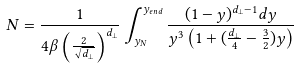<formula> <loc_0><loc_0><loc_500><loc_500>N = \frac { 1 } { 4 \beta \left ( \frac { 2 } { \sqrt { d _ { \perp } } } \right ) ^ { d _ { \perp } } } \int _ { y _ { N } } ^ { y _ { e n d } } \frac { ( 1 - y ) ^ { d _ { \perp } - 1 } d y } { y ^ { 3 } \left ( 1 + ( \frac { d _ { \perp } } { 4 } - \frac { 3 } { 2 } ) y \right ) }</formula> 